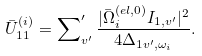<formula> <loc_0><loc_0><loc_500><loc_500>\bar { U } _ { 1 1 } ^ { ( i ) } = \sum \nolimits _ { v ^ { \prime } } ^ { \prime } \frac { | { \bar { \Omega } } _ { i } ^ { ( e l , 0 ) } I _ { 1 , v ^ { \prime } } | ^ { 2 } } { 4 \Delta _ { 1 v ^ { \prime } , \omega _ { i } } } .</formula> 